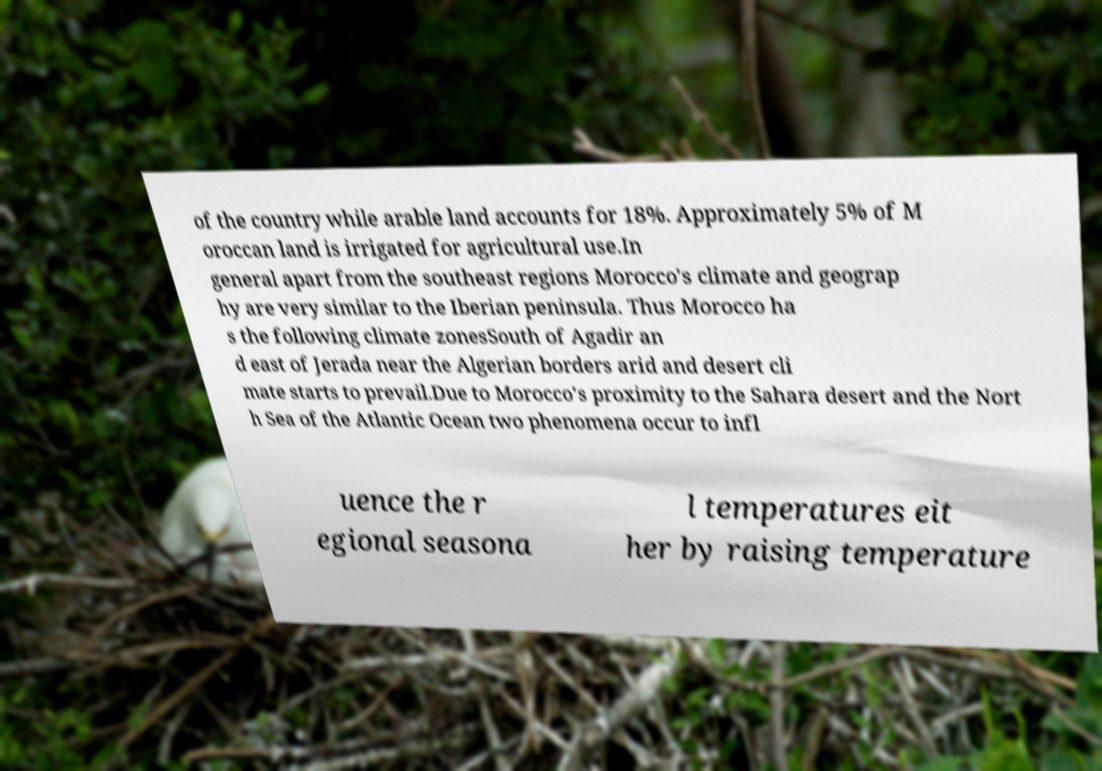What messages or text are displayed in this image? I need them in a readable, typed format. of the country while arable land accounts for 18%. Approximately 5% of M oroccan land is irrigated for agricultural use.In general apart from the southeast regions Morocco's climate and geograp hy are very similar to the Iberian peninsula. Thus Morocco ha s the following climate zonesSouth of Agadir an d east of Jerada near the Algerian borders arid and desert cli mate starts to prevail.Due to Morocco's proximity to the Sahara desert and the Nort h Sea of the Atlantic Ocean two phenomena occur to infl uence the r egional seasona l temperatures eit her by raising temperature 